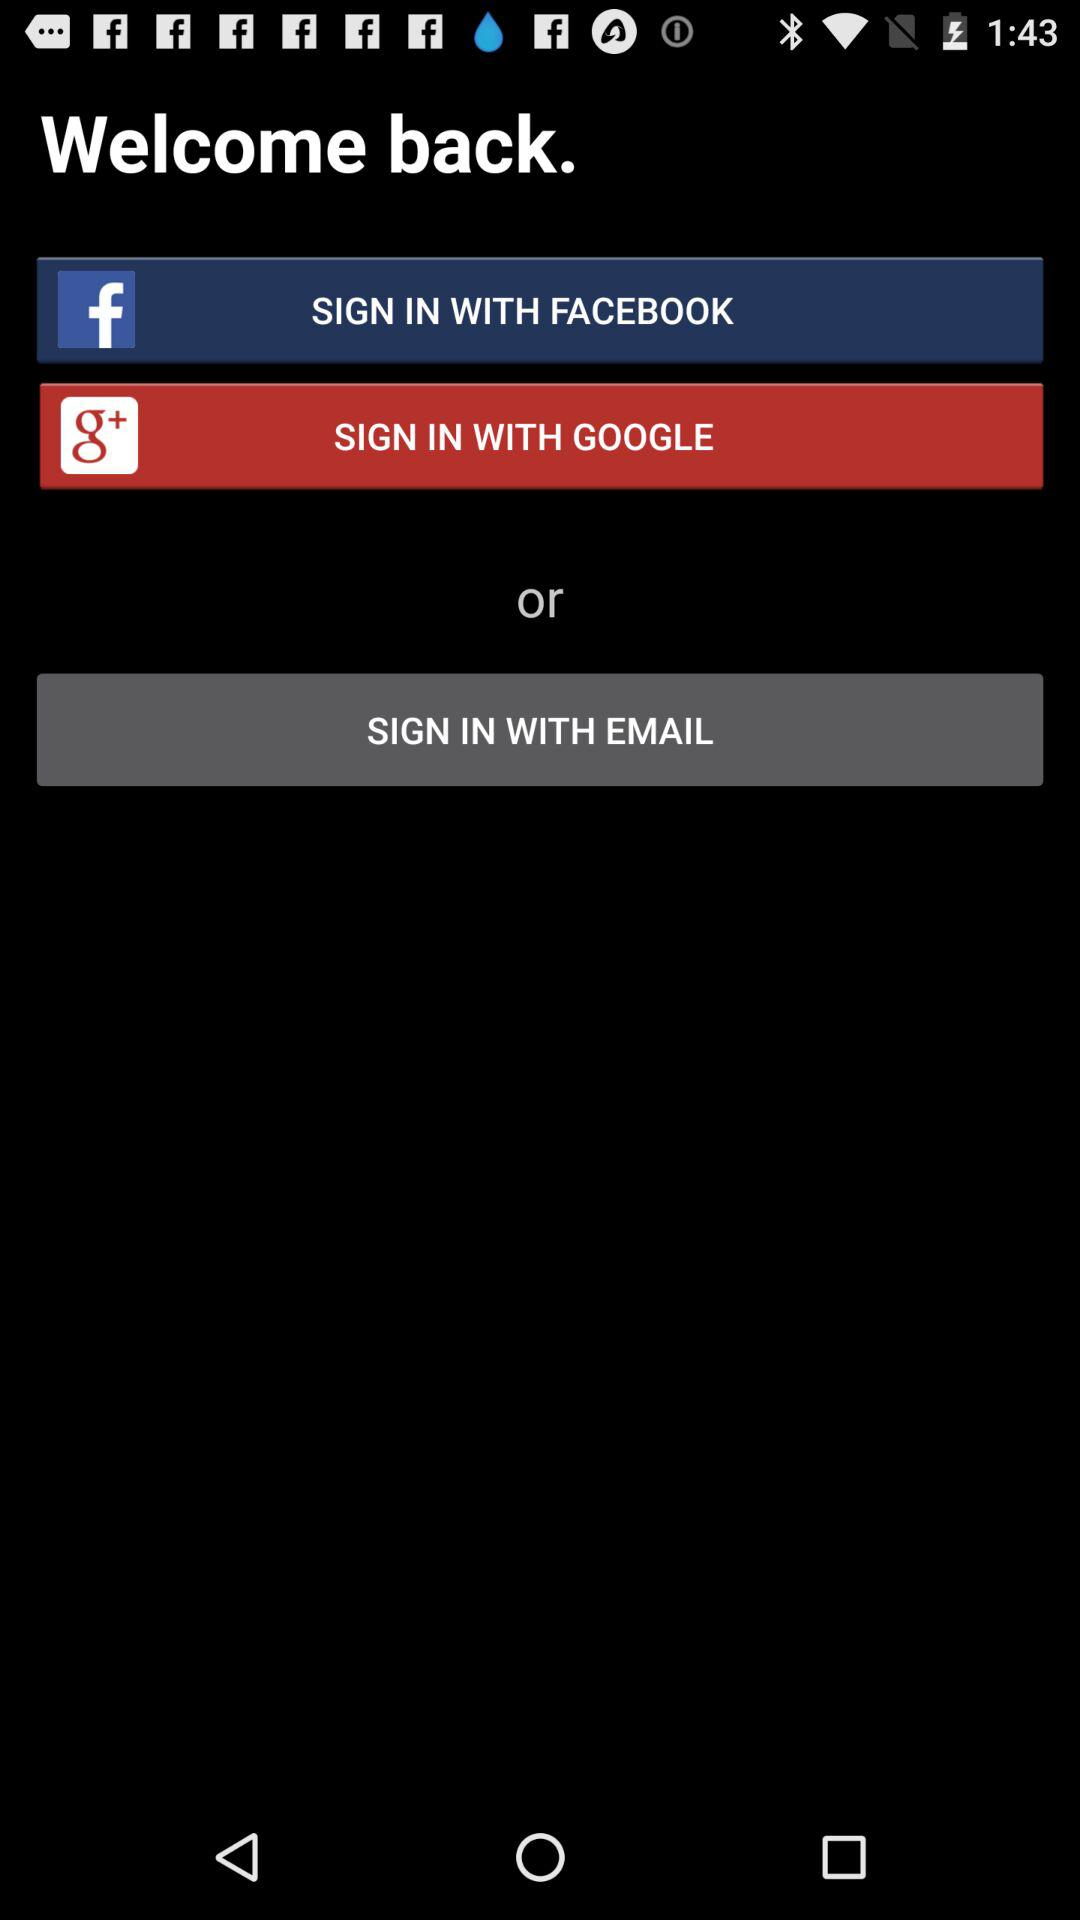What are the different options through which we can sign in? The different options are "FACEBOOK", "GOOGLE" and "EMAIL". 